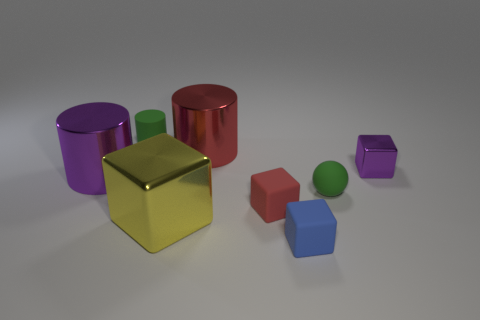Subtract all big red cylinders. How many cylinders are left? 2 Subtract 1 balls. How many balls are left? 0 Subtract all green cylinders. How many cylinders are left? 2 Add 1 tiny red metal balls. How many objects exist? 9 Subtract all balls. How many objects are left? 7 Add 5 big purple cylinders. How many big purple cylinders are left? 6 Add 7 blue shiny blocks. How many blue shiny blocks exist? 7 Subtract 0 brown spheres. How many objects are left? 8 Subtract all purple spheres. Subtract all cyan blocks. How many spheres are left? 1 Subtract all gray blocks. How many purple cylinders are left? 1 